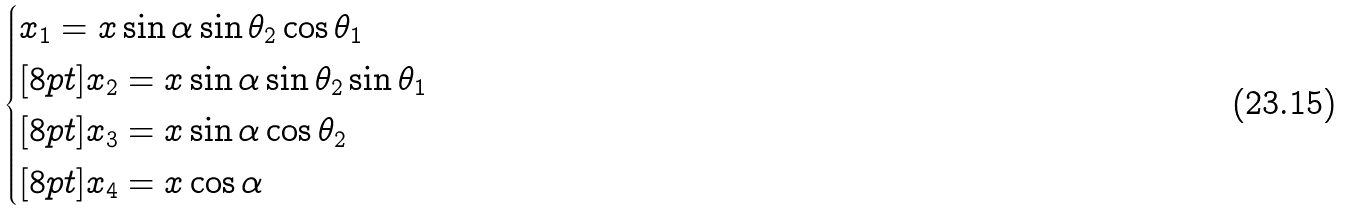<formula> <loc_0><loc_0><loc_500><loc_500>\begin{cases} x _ { 1 } = x \sin { \alpha } \sin { \theta _ { 2 } } \cos { \theta _ { 1 } } \\ [ 8 p t ] x _ { 2 } = x \sin { \alpha } \sin { \theta _ { 2 } } \sin { \theta _ { 1 } } \\ [ 8 p t ] x _ { 3 } = x \sin { \alpha } \cos { \theta _ { 2 } } \\ [ 8 p t ] x _ { 4 } = x \cos { \alpha } \end{cases}</formula> 